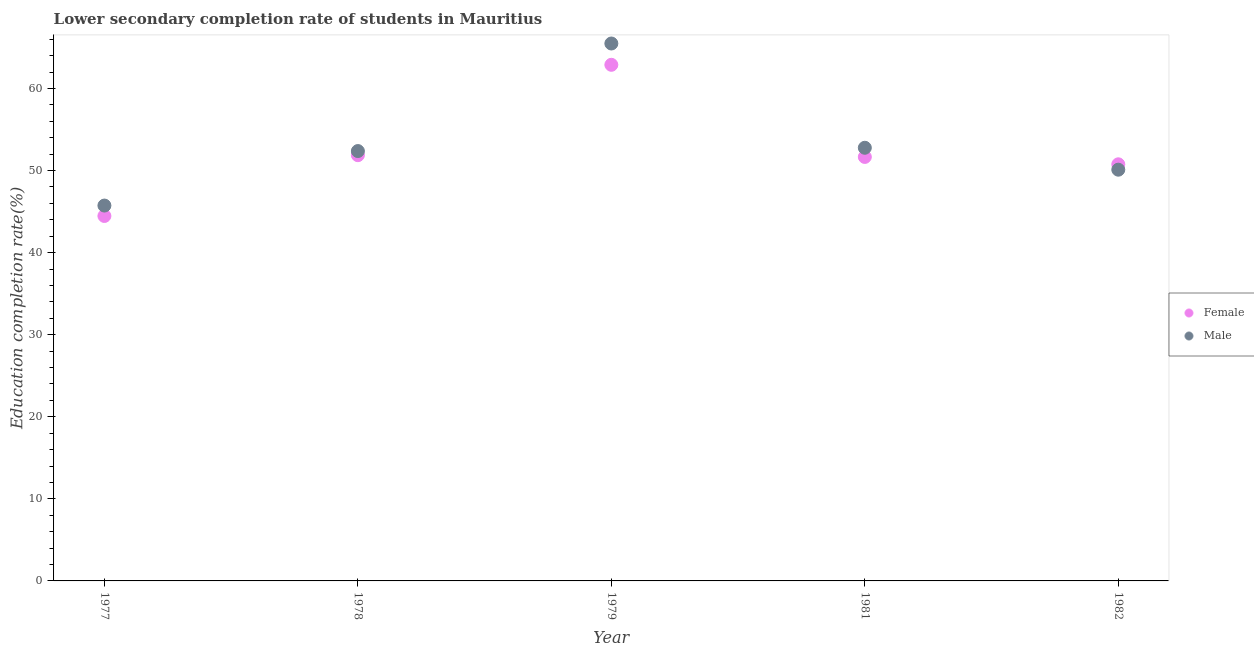How many different coloured dotlines are there?
Offer a terse response. 2. Is the number of dotlines equal to the number of legend labels?
Offer a terse response. Yes. What is the education completion rate of female students in 1978?
Make the answer very short. 51.87. Across all years, what is the maximum education completion rate of female students?
Offer a very short reply. 62.88. Across all years, what is the minimum education completion rate of female students?
Offer a terse response. 44.46. In which year was the education completion rate of male students maximum?
Offer a very short reply. 1979. In which year was the education completion rate of female students minimum?
Provide a succinct answer. 1977. What is the total education completion rate of female students in the graph?
Offer a terse response. 261.63. What is the difference between the education completion rate of female students in 1978 and that in 1979?
Your answer should be compact. -11.01. What is the difference between the education completion rate of female students in 1979 and the education completion rate of male students in 1978?
Keep it short and to the point. 10.51. What is the average education completion rate of male students per year?
Offer a terse response. 53.29. In the year 1982, what is the difference between the education completion rate of male students and education completion rate of female students?
Keep it short and to the point. -0.66. What is the ratio of the education completion rate of male students in 1979 to that in 1982?
Keep it short and to the point. 1.31. Is the difference between the education completion rate of male students in 1977 and 1979 greater than the difference between the education completion rate of female students in 1977 and 1979?
Your answer should be compact. No. What is the difference between the highest and the second highest education completion rate of male students?
Provide a short and direct response. 12.7. What is the difference between the highest and the lowest education completion rate of female students?
Give a very brief answer. 18.42. Is the sum of the education completion rate of male students in 1978 and 1982 greater than the maximum education completion rate of female students across all years?
Offer a terse response. Yes. Is the education completion rate of male students strictly greater than the education completion rate of female students over the years?
Provide a succinct answer. No. How many dotlines are there?
Provide a succinct answer. 2. What is the difference between two consecutive major ticks on the Y-axis?
Provide a short and direct response. 10. Are the values on the major ticks of Y-axis written in scientific E-notation?
Make the answer very short. No. Does the graph contain any zero values?
Provide a succinct answer. No. How many legend labels are there?
Your answer should be compact. 2. How are the legend labels stacked?
Your answer should be compact. Vertical. What is the title of the graph?
Your answer should be very brief. Lower secondary completion rate of students in Mauritius. Does "National Visitors" appear as one of the legend labels in the graph?
Your answer should be compact. No. What is the label or title of the Y-axis?
Offer a terse response. Education completion rate(%). What is the Education completion rate(%) in Female in 1977?
Give a very brief answer. 44.46. What is the Education completion rate(%) in Male in 1977?
Make the answer very short. 45.73. What is the Education completion rate(%) of Female in 1978?
Give a very brief answer. 51.87. What is the Education completion rate(%) in Male in 1978?
Provide a short and direct response. 52.37. What is the Education completion rate(%) of Female in 1979?
Make the answer very short. 62.88. What is the Education completion rate(%) in Male in 1979?
Your answer should be compact. 65.48. What is the Education completion rate(%) of Female in 1981?
Provide a short and direct response. 51.66. What is the Education completion rate(%) in Male in 1981?
Your response must be concise. 52.77. What is the Education completion rate(%) in Female in 1982?
Offer a very short reply. 50.76. What is the Education completion rate(%) of Male in 1982?
Ensure brevity in your answer.  50.1. Across all years, what is the maximum Education completion rate(%) in Female?
Ensure brevity in your answer.  62.88. Across all years, what is the maximum Education completion rate(%) of Male?
Provide a succinct answer. 65.48. Across all years, what is the minimum Education completion rate(%) of Female?
Offer a terse response. 44.46. Across all years, what is the minimum Education completion rate(%) of Male?
Give a very brief answer. 45.73. What is the total Education completion rate(%) in Female in the graph?
Your answer should be very brief. 261.63. What is the total Education completion rate(%) of Male in the graph?
Provide a short and direct response. 266.46. What is the difference between the Education completion rate(%) in Female in 1977 and that in 1978?
Give a very brief answer. -7.41. What is the difference between the Education completion rate(%) of Male in 1977 and that in 1978?
Make the answer very short. -6.64. What is the difference between the Education completion rate(%) in Female in 1977 and that in 1979?
Provide a succinct answer. -18.42. What is the difference between the Education completion rate(%) of Male in 1977 and that in 1979?
Provide a short and direct response. -19.74. What is the difference between the Education completion rate(%) of Female in 1977 and that in 1981?
Offer a terse response. -7.19. What is the difference between the Education completion rate(%) of Male in 1977 and that in 1981?
Offer a terse response. -7.04. What is the difference between the Education completion rate(%) of Female in 1977 and that in 1982?
Offer a very short reply. -6.3. What is the difference between the Education completion rate(%) of Male in 1977 and that in 1982?
Your response must be concise. -4.37. What is the difference between the Education completion rate(%) in Female in 1978 and that in 1979?
Offer a very short reply. -11.01. What is the difference between the Education completion rate(%) of Male in 1978 and that in 1979?
Offer a very short reply. -13.1. What is the difference between the Education completion rate(%) of Female in 1978 and that in 1981?
Provide a succinct answer. 0.21. What is the difference between the Education completion rate(%) of Male in 1978 and that in 1981?
Keep it short and to the point. -0.4. What is the difference between the Education completion rate(%) of Female in 1978 and that in 1982?
Offer a very short reply. 1.11. What is the difference between the Education completion rate(%) in Male in 1978 and that in 1982?
Offer a very short reply. 2.27. What is the difference between the Education completion rate(%) of Female in 1979 and that in 1981?
Provide a short and direct response. 11.23. What is the difference between the Education completion rate(%) of Male in 1979 and that in 1981?
Your response must be concise. 12.7. What is the difference between the Education completion rate(%) of Female in 1979 and that in 1982?
Provide a succinct answer. 12.12. What is the difference between the Education completion rate(%) in Male in 1979 and that in 1982?
Your answer should be compact. 15.37. What is the difference between the Education completion rate(%) in Female in 1981 and that in 1982?
Keep it short and to the point. 0.9. What is the difference between the Education completion rate(%) of Male in 1981 and that in 1982?
Give a very brief answer. 2.67. What is the difference between the Education completion rate(%) of Female in 1977 and the Education completion rate(%) of Male in 1978?
Give a very brief answer. -7.91. What is the difference between the Education completion rate(%) in Female in 1977 and the Education completion rate(%) in Male in 1979?
Your answer should be compact. -21.01. What is the difference between the Education completion rate(%) of Female in 1977 and the Education completion rate(%) of Male in 1981?
Provide a short and direct response. -8.31. What is the difference between the Education completion rate(%) of Female in 1977 and the Education completion rate(%) of Male in 1982?
Your response must be concise. -5.64. What is the difference between the Education completion rate(%) of Female in 1978 and the Education completion rate(%) of Male in 1979?
Give a very brief answer. -13.61. What is the difference between the Education completion rate(%) of Female in 1978 and the Education completion rate(%) of Male in 1981?
Offer a terse response. -0.9. What is the difference between the Education completion rate(%) of Female in 1978 and the Education completion rate(%) of Male in 1982?
Your response must be concise. 1.77. What is the difference between the Education completion rate(%) in Female in 1979 and the Education completion rate(%) in Male in 1981?
Make the answer very short. 10.11. What is the difference between the Education completion rate(%) in Female in 1979 and the Education completion rate(%) in Male in 1982?
Make the answer very short. 12.78. What is the difference between the Education completion rate(%) in Female in 1981 and the Education completion rate(%) in Male in 1982?
Keep it short and to the point. 1.55. What is the average Education completion rate(%) of Female per year?
Keep it short and to the point. 52.33. What is the average Education completion rate(%) in Male per year?
Your response must be concise. 53.29. In the year 1977, what is the difference between the Education completion rate(%) of Female and Education completion rate(%) of Male?
Make the answer very short. -1.27. In the year 1978, what is the difference between the Education completion rate(%) of Female and Education completion rate(%) of Male?
Your response must be concise. -0.5. In the year 1979, what is the difference between the Education completion rate(%) of Female and Education completion rate(%) of Male?
Give a very brief answer. -2.6. In the year 1981, what is the difference between the Education completion rate(%) in Female and Education completion rate(%) in Male?
Provide a short and direct response. -1.12. In the year 1982, what is the difference between the Education completion rate(%) of Female and Education completion rate(%) of Male?
Offer a terse response. 0.66. What is the ratio of the Education completion rate(%) in Female in 1977 to that in 1978?
Provide a short and direct response. 0.86. What is the ratio of the Education completion rate(%) of Male in 1977 to that in 1978?
Give a very brief answer. 0.87. What is the ratio of the Education completion rate(%) in Female in 1977 to that in 1979?
Keep it short and to the point. 0.71. What is the ratio of the Education completion rate(%) of Male in 1977 to that in 1979?
Provide a succinct answer. 0.7. What is the ratio of the Education completion rate(%) of Female in 1977 to that in 1981?
Ensure brevity in your answer.  0.86. What is the ratio of the Education completion rate(%) in Male in 1977 to that in 1981?
Ensure brevity in your answer.  0.87. What is the ratio of the Education completion rate(%) in Female in 1977 to that in 1982?
Offer a terse response. 0.88. What is the ratio of the Education completion rate(%) of Male in 1977 to that in 1982?
Provide a short and direct response. 0.91. What is the ratio of the Education completion rate(%) in Female in 1978 to that in 1979?
Provide a succinct answer. 0.82. What is the ratio of the Education completion rate(%) of Male in 1978 to that in 1979?
Offer a terse response. 0.8. What is the ratio of the Education completion rate(%) in Female in 1978 to that in 1982?
Offer a terse response. 1.02. What is the ratio of the Education completion rate(%) of Male in 1978 to that in 1982?
Provide a succinct answer. 1.05. What is the ratio of the Education completion rate(%) in Female in 1979 to that in 1981?
Offer a terse response. 1.22. What is the ratio of the Education completion rate(%) in Male in 1979 to that in 1981?
Your response must be concise. 1.24. What is the ratio of the Education completion rate(%) in Female in 1979 to that in 1982?
Offer a very short reply. 1.24. What is the ratio of the Education completion rate(%) of Male in 1979 to that in 1982?
Offer a terse response. 1.31. What is the ratio of the Education completion rate(%) in Female in 1981 to that in 1982?
Ensure brevity in your answer.  1.02. What is the ratio of the Education completion rate(%) in Male in 1981 to that in 1982?
Keep it short and to the point. 1.05. What is the difference between the highest and the second highest Education completion rate(%) in Female?
Your answer should be compact. 11.01. What is the difference between the highest and the second highest Education completion rate(%) of Male?
Keep it short and to the point. 12.7. What is the difference between the highest and the lowest Education completion rate(%) in Female?
Make the answer very short. 18.42. What is the difference between the highest and the lowest Education completion rate(%) of Male?
Your answer should be compact. 19.74. 